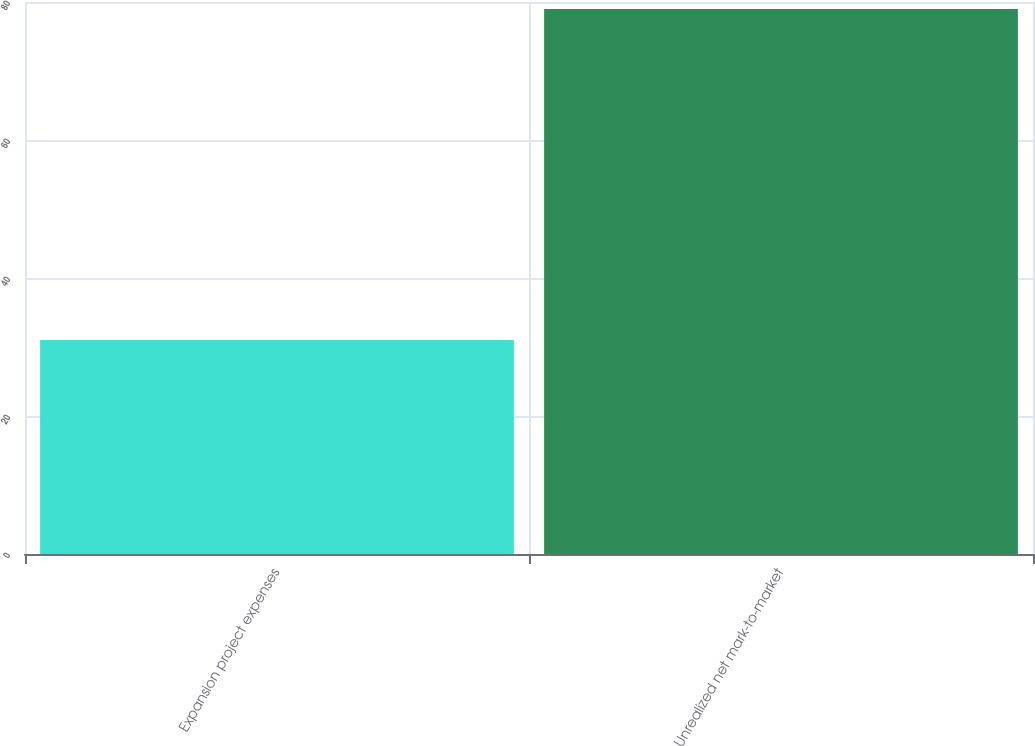<chart> <loc_0><loc_0><loc_500><loc_500><bar_chart><fcel>Expansion project expenses<fcel>Unrealized net mark-to-market<nl><fcel>31<fcel>79<nl></chart> 